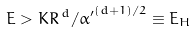<formula> <loc_0><loc_0><loc_500><loc_500>E > K R ^ { \, d } / { \alpha ^ { \prime } } ^ { ( d + 1 ) / 2 } \equiv E _ { H }</formula> 